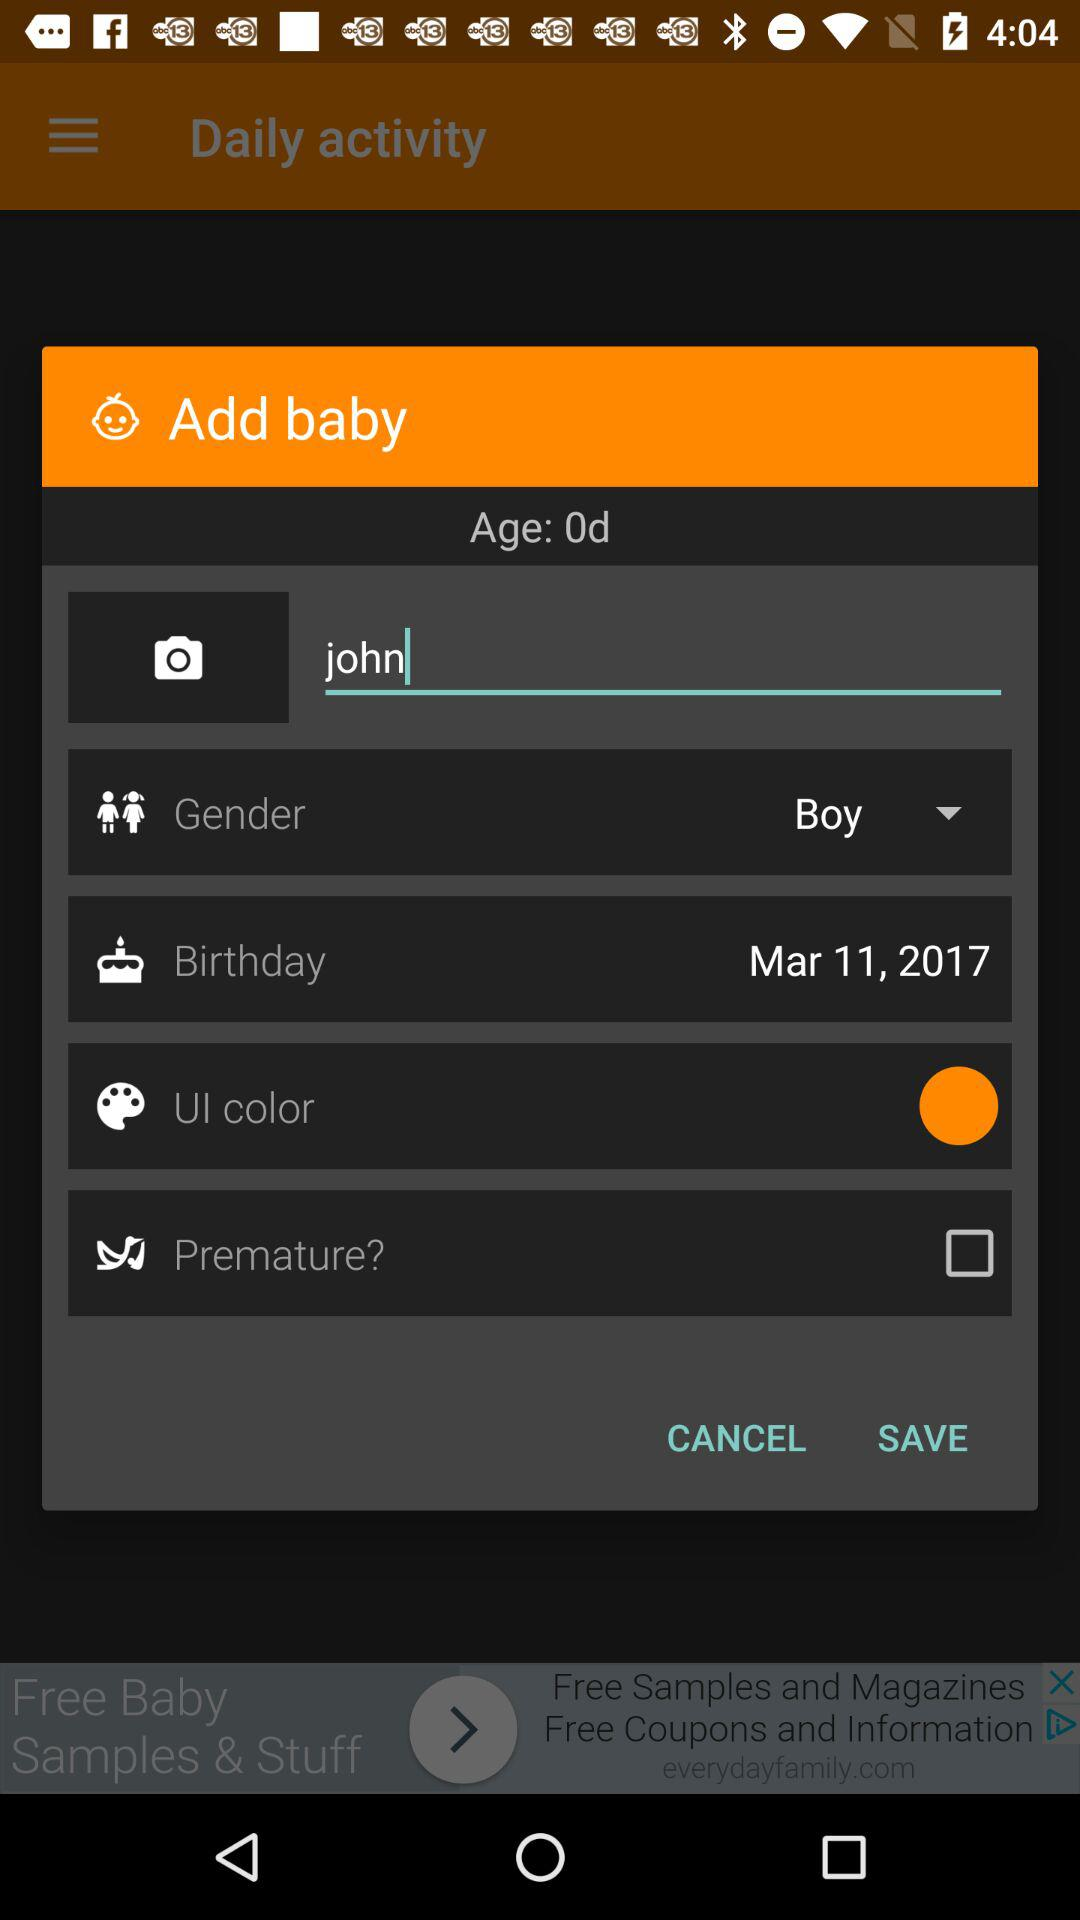What is the age of the baby? The age of the baby is 0 days old. 